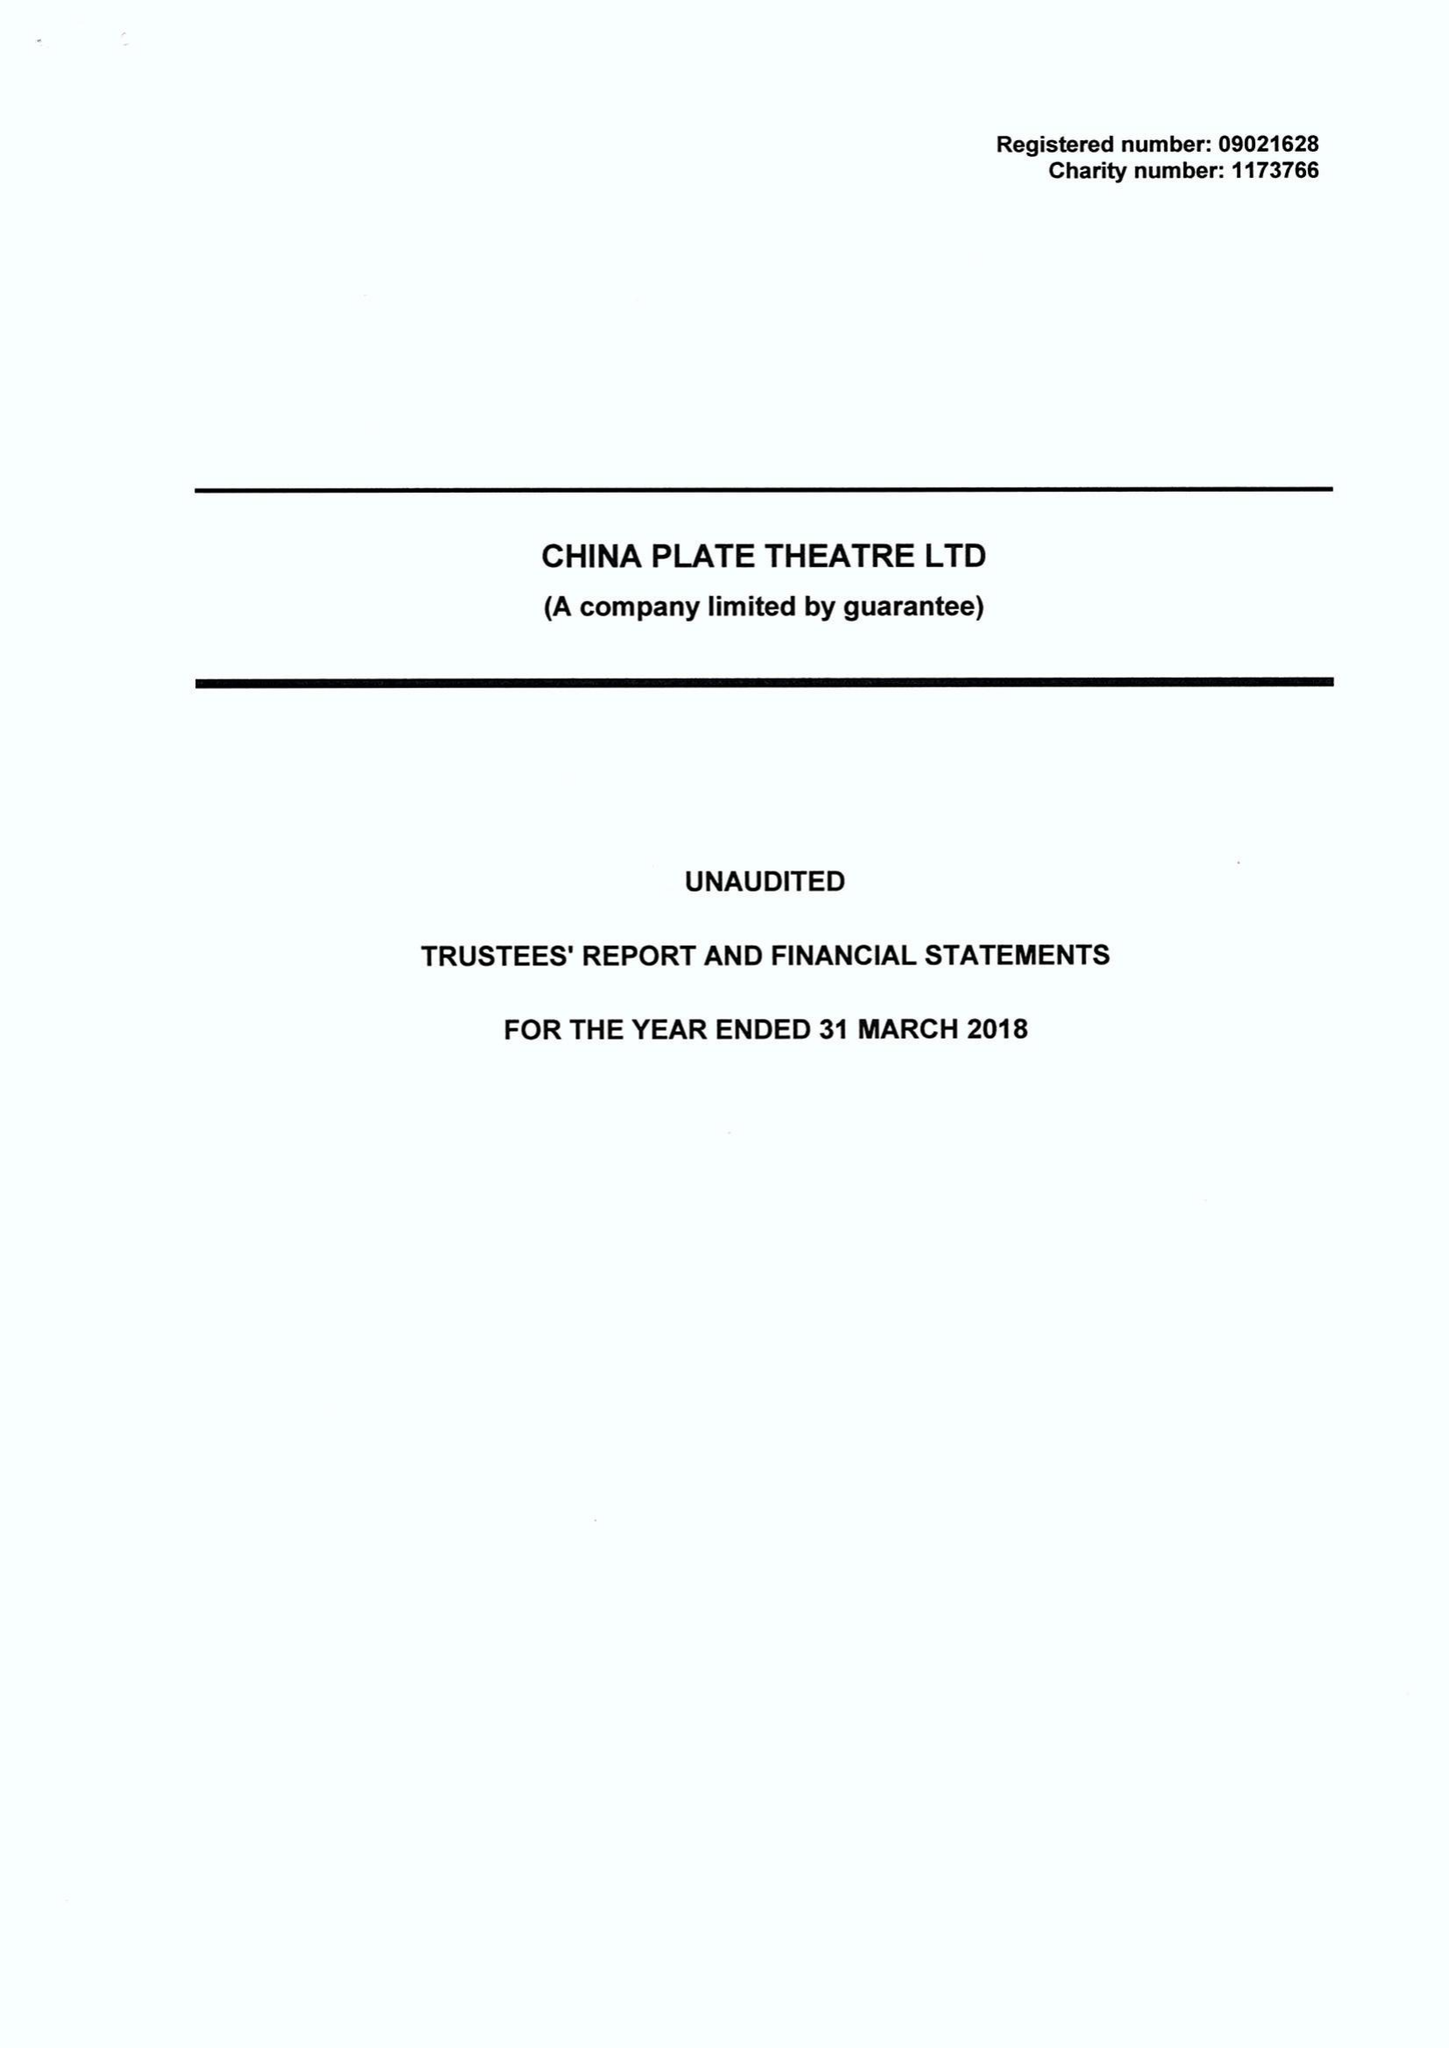What is the value for the address__post_town?
Answer the question using a single word or phrase. BIRMINGHAM 